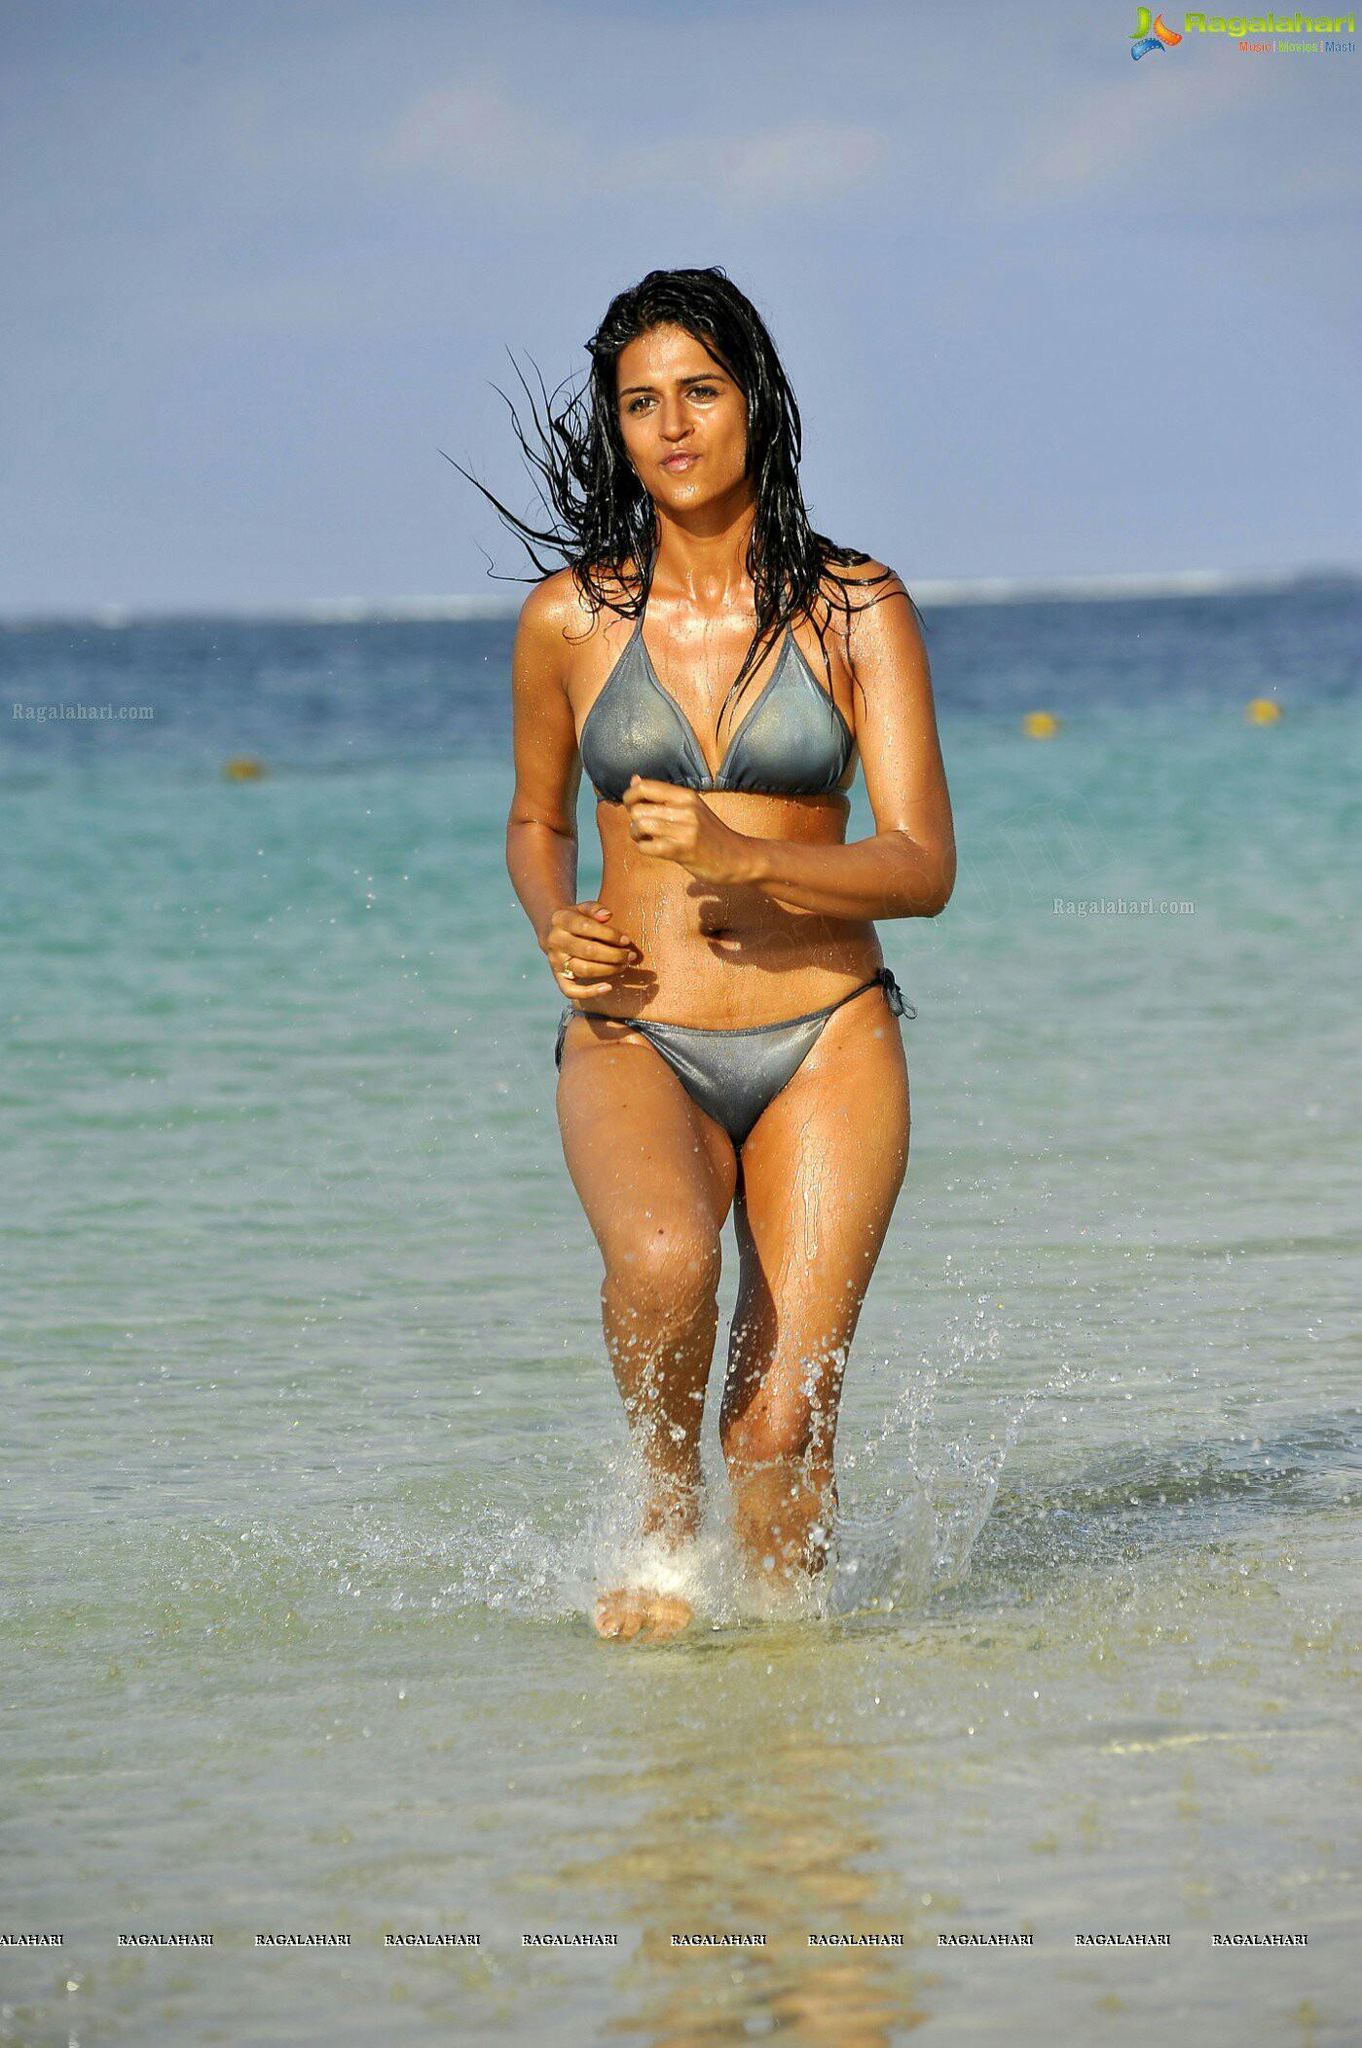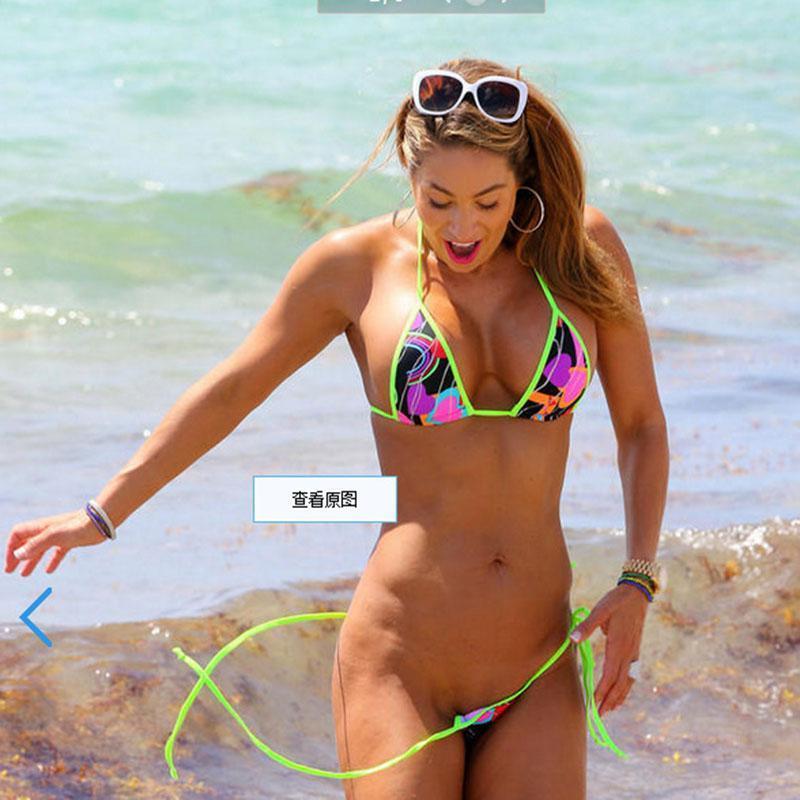The first image is the image on the left, the second image is the image on the right. Analyze the images presented: Is the assertion "In 1 of the images, 1 girl with a pink bikini and 1 girl with a green bikini is sitting." valid? Answer yes or no. No. The first image is the image on the left, the second image is the image on the right. Evaluate the accuracy of this statement regarding the images: "There are three women at the beach.". Is it true? Answer yes or no. No. 